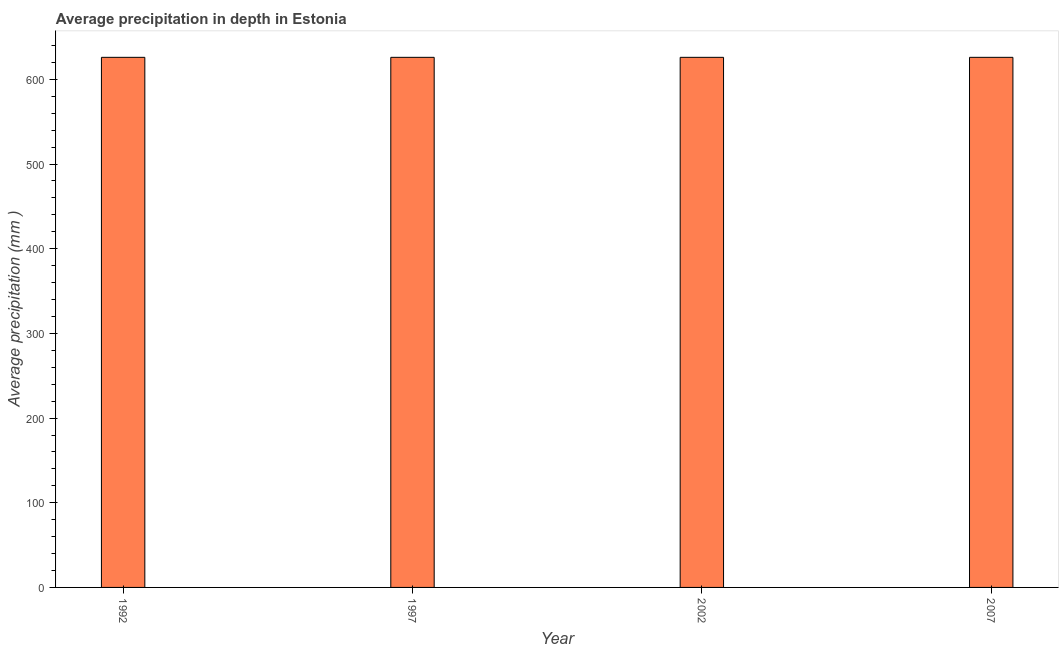Does the graph contain grids?
Make the answer very short. No. What is the title of the graph?
Offer a terse response. Average precipitation in depth in Estonia. What is the label or title of the Y-axis?
Offer a very short reply. Average precipitation (mm ). What is the average precipitation in depth in 1992?
Your response must be concise. 626. Across all years, what is the maximum average precipitation in depth?
Your answer should be very brief. 626. Across all years, what is the minimum average precipitation in depth?
Give a very brief answer. 626. What is the sum of the average precipitation in depth?
Provide a succinct answer. 2504. What is the difference between the average precipitation in depth in 1992 and 1997?
Offer a terse response. 0. What is the average average precipitation in depth per year?
Make the answer very short. 626. What is the median average precipitation in depth?
Offer a very short reply. 626. What is the ratio of the average precipitation in depth in 1992 to that in 1997?
Ensure brevity in your answer.  1. Is the average precipitation in depth in 1992 less than that in 2007?
Ensure brevity in your answer.  No. What is the difference between the highest and the second highest average precipitation in depth?
Offer a terse response. 0. In how many years, is the average precipitation in depth greater than the average average precipitation in depth taken over all years?
Your response must be concise. 0. Are all the bars in the graph horizontal?
Your response must be concise. No. What is the difference between two consecutive major ticks on the Y-axis?
Your answer should be compact. 100. Are the values on the major ticks of Y-axis written in scientific E-notation?
Your answer should be compact. No. What is the Average precipitation (mm ) of 1992?
Give a very brief answer. 626. What is the Average precipitation (mm ) in 1997?
Your answer should be compact. 626. What is the Average precipitation (mm ) of 2002?
Ensure brevity in your answer.  626. What is the Average precipitation (mm ) of 2007?
Offer a terse response. 626. What is the difference between the Average precipitation (mm ) in 1997 and 2002?
Your answer should be very brief. 0. What is the difference between the Average precipitation (mm ) in 2002 and 2007?
Provide a succinct answer. 0. What is the ratio of the Average precipitation (mm ) in 1992 to that in 1997?
Offer a terse response. 1. What is the ratio of the Average precipitation (mm ) in 1992 to that in 2002?
Keep it short and to the point. 1. What is the ratio of the Average precipitation (mm ) in 1997 to that in 2007?
Ensure brevity in your answer.  1. What is the ratio of the Average precipitation (mm ) in 2002 to that in 2007?
Your answer should be compact. 1. 